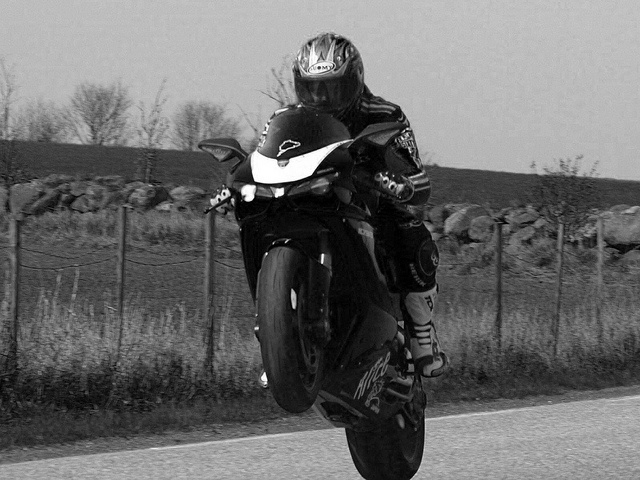Describe the objects in this image and their specific colors. I can see motorcycle in darkgray, black, gray, and white tones and people in darkgray, black, gray, and lightgray tones in this image. 